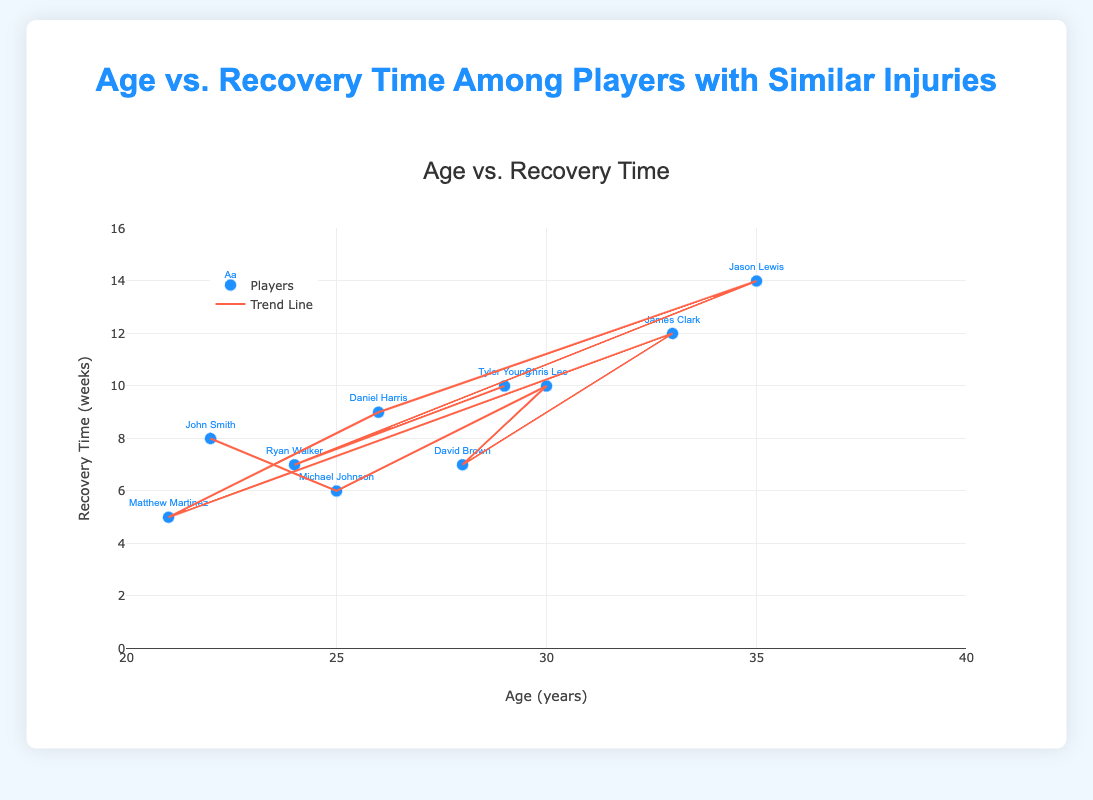What is the title of the plot? The title of the plot is displayed at the top and reads "Age vs. Recovery Time Among Players with Similar Injuries".
Answer: Age vs. Recovery Time Among Players with Similar Injuries What are the axes labels? The x-axis label is 'Age (years)', and the y-axis label is 'Recovery Time (weeks)'.
Answer: Age (years), Recovery Time (weeks) How many players are represented in this scatter plot? Each player corresponds to one data point. Counting them gives 10 data points in total.
Answer: 10 Which player has the shortest recovery time and what is it? The point with the lowest y-value represents the shortest recovery time. Matthew Martinez has the shortest recovery time of 5 weeks.
Answer: Matthew Martinez, 5 weeks How many players are aged 30 or older? By counting the data points to the right of the 30-year mark on the x-axis, we see there are four players aged 30 or older: Chris Lee, James Clark, Jason Lewis, and Tyler Young.
Answer: 4 What is the average recovery time of players above the age of 30? Players above 30: James Clark (12), Jason Lewis (14), Chris Lee (10), Tyler Young (10). The total is 12 + 14 + 10 + 10 = 46. The average is 46 / 4 = 11.5 weeks.
Answer: 11.5 weeks Do younger players (under 25) generally have shorter recovery times than older players (25 and above)? By comparing the y-values (recovery times) of younger players vs. older players, we see younger players (21-24) have times 5, 8, 7, 6, averaging 6.5 weeks. Older players (28-35) have times 7, 10, 12, 14, 9, 10, averaging 10.3 weeks.
Answer: Yes Is there a visible trend between age and recovery time based on the trend line? The trend line, which slopes upwards, suggests that as age increases, the recovery time also tends to increase.
Answer: Yes Who is the player with the highest recovery time, and what is it? The data point with the highest y-value represents the longest recovery time. Jason Lewis has the longest recovery time of 14 weeks.
Answer: Jason Lewis, 14 weeks What is the difference in recovery time between the youngest and oldest players? The youngest player, Matthew Martinez (21), has a recovery time of 5 weeks. The oldest player, Jason Lewis (35), has a recovery time of 14 weeks. The difference is 14 - 5 = 9 weeks.
Answer: 9 weeks 